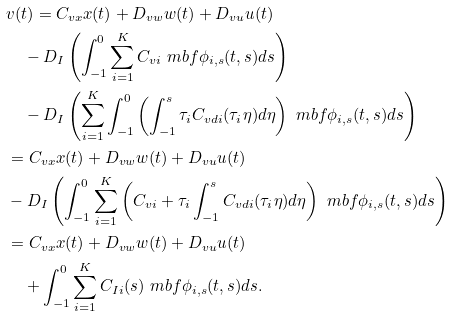<formula> <loc_0><loc_0><loc_500><loc_500>& v ( t ) = C _ { v x } x ( t ) + D _ { v w } w ( t ) + D _ { v u } u ( t ) \\ & \quad - D _ { I } \left ( \int _ { - 1 } ^ { 0 } \sum _ { i = 1 } ^ { K } C _ { v i } \ m b f \phi _ { i , s } ( t , s ) d s \right ) \\ & \quad - D _ { I } \left ( \sum _ { i = 1 } ^ { K } \int _ { - 1 } ^ { 0 } \left ( \int _ { - 1 } ^ { s } \tau _ { i } C _ { v d i } ( \tau _ { i } \eta ) d \eta \right ) \ m b f \phi _ { i , s } ( t , s ) d s \right ) \\ & = C _ { v x } x ( t ) + D _ { v w } w ( t ) + D _ { v u } u ( t ) \\ & - D _ { I } \left ( \int _ { - 1 } ^ { 0 } \sum _ { i = 1 } ^ { K } \left ( C _ { v i } + \tau _ { i } \int _ { - 1 } ^ { s } C _ { v d i } ( \tau _ { i } \eta ) d \eta \right ) \ m b f \phi _ { i , s } ( t , s ) d s \right ) \\ & = C _ { v x } x ( t ) + D _ { v w } w ( t ) + D _ { v u } u ( t ) \\ & \quad + \int _ { - 1 } ^ { 0 } \sum _ { i = 1 } ^ { K } C _ { I i } ( s ) \ m b f \phi _ { i , s } ( t , s ) d s .</formula> 